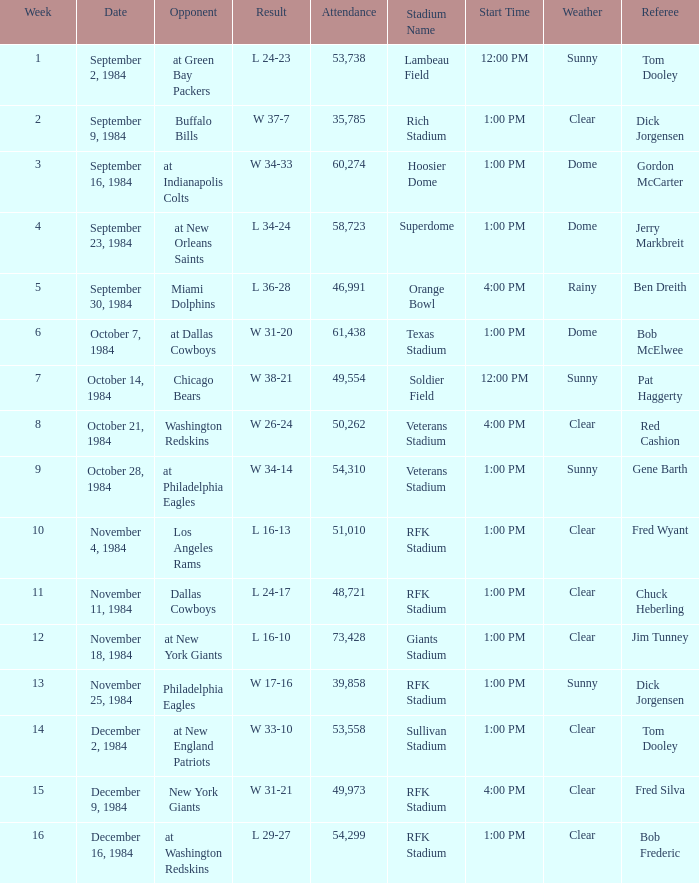Who was the opponent on October 14, 1984? Chicago Bears. 